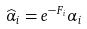Convert formula to latex. <formula><loc_0><loc_0><loc_500><loc_500>\widehat { \alpha } _ { i } = e ^ { - F _ { i } } \alpha _ { i }</formula> 